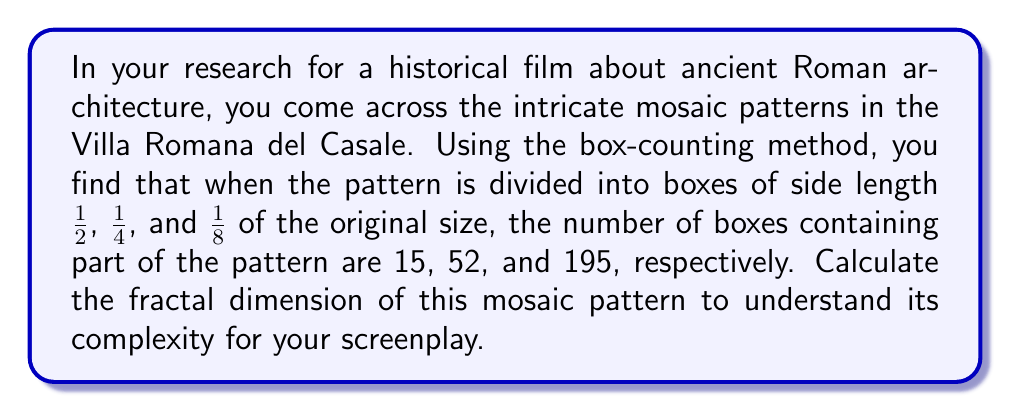What is the answer to this math problem? To calculate the fractal dimension using the box-counting method, we'll follow these steps:

1) The general formula for fractal dimension (D) is:

   $$D = \lim_{ε \to 0} \frac{\log N(ε)}{\log(1/ε)}$$

   where N(ε) is the number of boxes of side length ε needed to cover the pattern.

2) We have three data points:
   - ε₁ = 1/2,  N(ε₁) = 15
   - ε₂ = 1/4,  N(ε₂) = 52
   - ε₃ = 1/8,  N(ε₃) = 195

3) We'll use the slope of the log-log plot to approximate D:

   $$D ≈ \frac{\log(N(ε_2)) - \log(N(ε_1))}{\log(1/ε_2) - \log(1/ε_1)}$$

4) Let's calculate using the first two data points:

   $$D ≈ \frac{\log(52) - \log(15)}{\log(4) - \log(2)} = \frac{\log(52/15)}{\log(2)} ≈ 1.7949$$

5) Now, let's calculate using the last two data points:

   $$D ≈ \frac{\log(195) - \log(52)}{\log(8) - \log(4)} = \frac{\log(195/52)}{\log(2)} ≈ 1.9069$$

6) We'll take the average of these two calculations:

   $$D ≈ \frac{1.7949 + 1.9069}{2} ≈ 1.8509$$

This fractal dimension indicates that the mosaic pattern is more complex than a simple line (D=1) but less complex than a filled plane (D=2), suggesting intricate detail that fills space more than a line but not completely.
Answer: $D ≈ 1.8509$ 